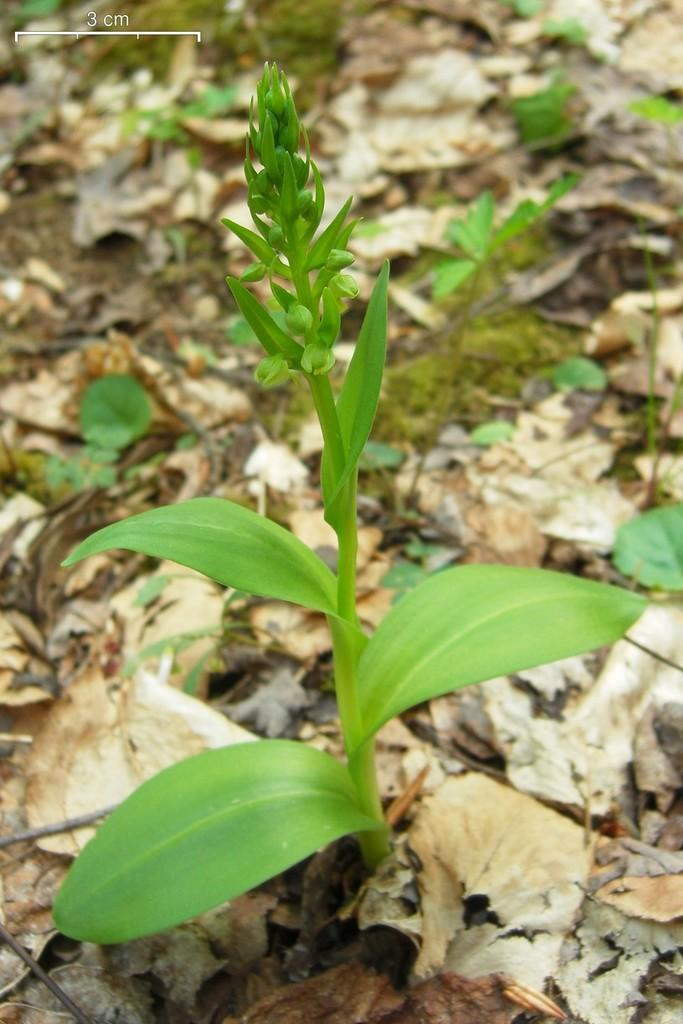What type of plant can be seen in the image? There is a green plant in the image. What can be found on the ground in the image? There are dried leaves on the ground in the image. What type of bread is being used to build the carpenter's bench in the image? There is no carpenter or bench present in the image, and no bread is mentioned or visible. 